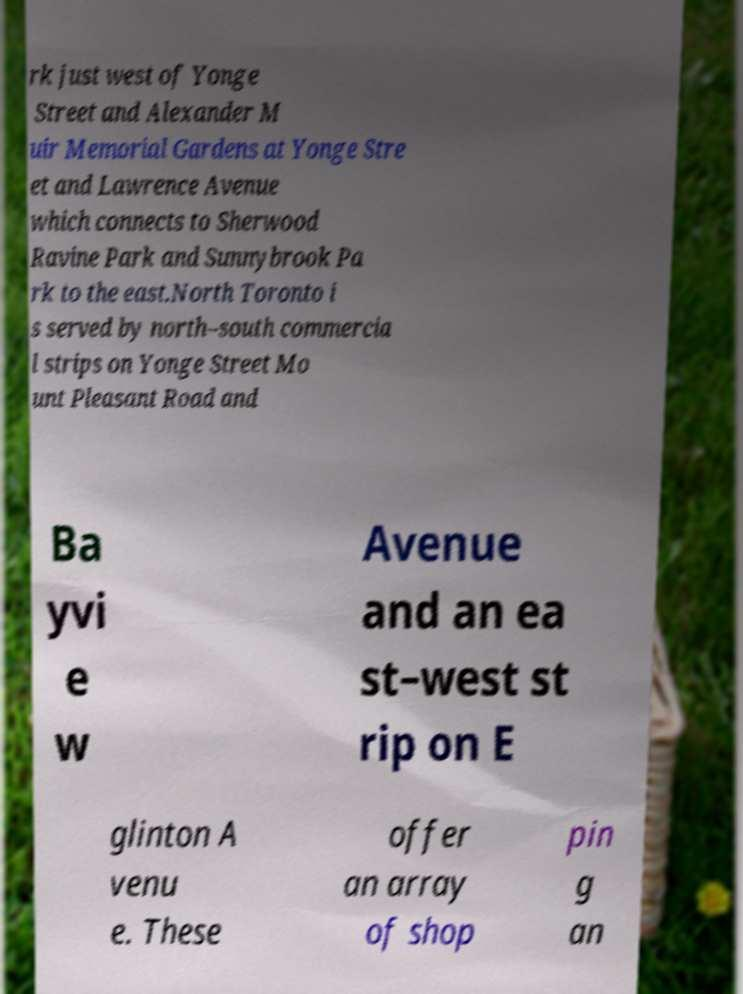Please read and relay the text visible in this image. What does it say? rk just west of Yonge Street and Alexander M uir Memorial Gardens at Yonge Stre et and Lawrence Avenue which connects to Sherwood Ravine Park and Sunnybrook Pa rk to the east.North Toronto i s served by north–south commercia l strips on Yonge Street Mo unt Pleasant Road and Ba yvi e w Avenue and an ea st–west st rip on E glinton A venu e. These offer an array of shop pin g an 